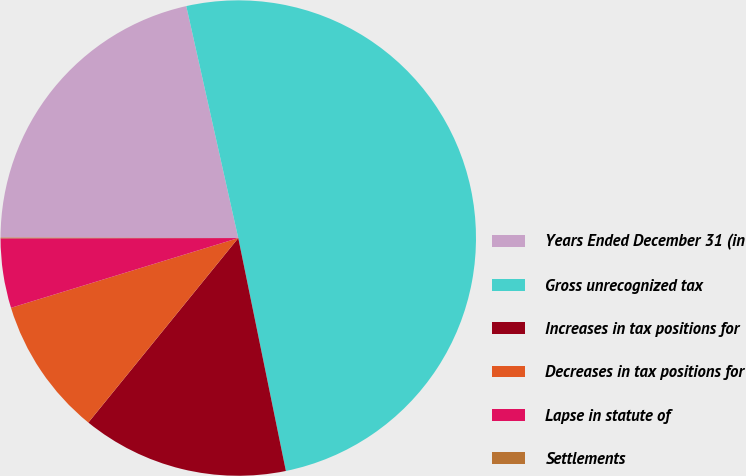Convert chart. <chart><loc_0><loc_0><loc_500><loc_500><pie_chart><fcel>Years Ended December 31 (in<fcel>Gross unrecognized tax<fcel>Increases in tax positions for<fcel>Decreases in tax positions for<fcel>Lapse in statute of<fcel>Settlements<nl><fcel>21.46%<fcel>50.3%<fcel>14.07%<fcel>9.4%<fcel>4.72%<fcel>0.05%<nl></chart> 